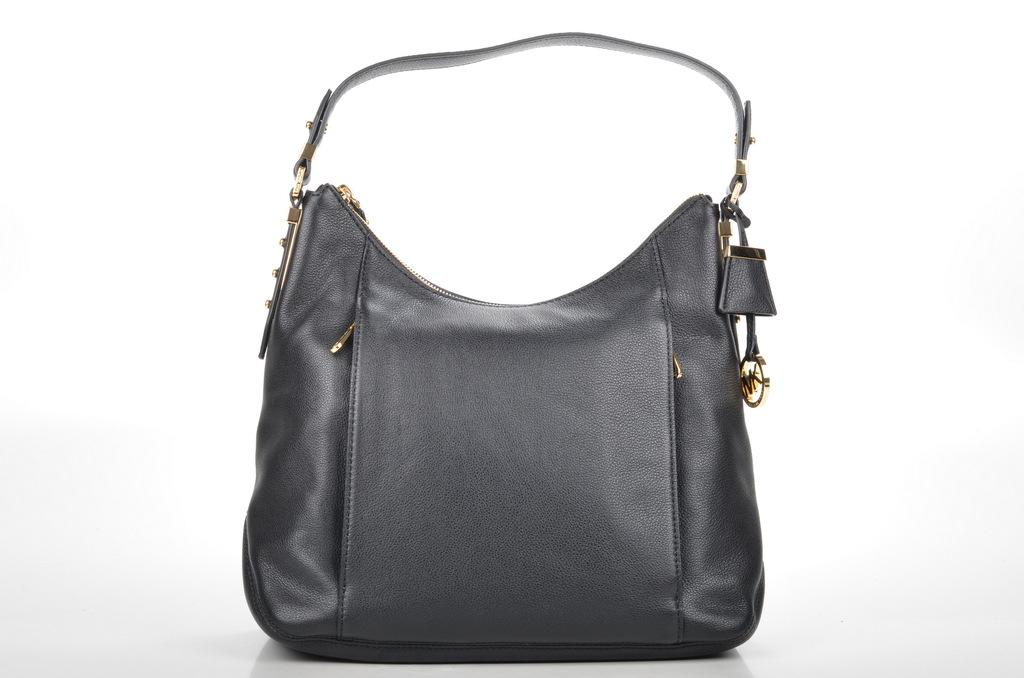What is the color of the bag in the image? The bag in the image is black. What feature does the bag have to secure it? The bag has a belt. Is there any additional accessory attached to the bag? Yes, there is a chain attached to the bag. Can you see a net in the image? No, there is no net present in the image. Is there a stream visible in the image? No, there is no stream visible in the image. 